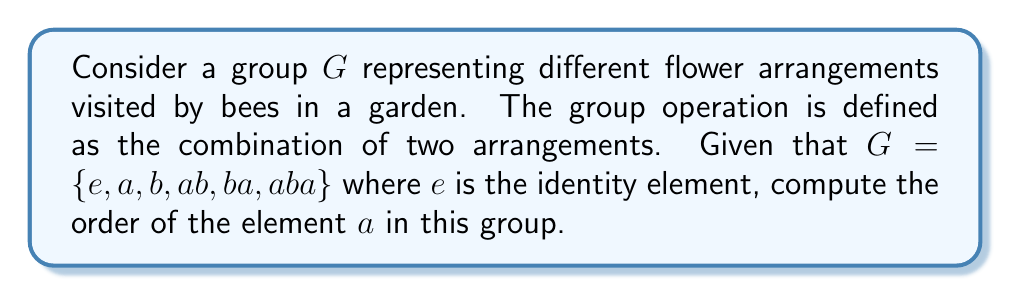What is the answer to this math problem? To find the order of element $a$ in group $G$, we need to determine the smallest positive integer $n$ such that $a^n = e$, where $e$ is the identity element.

Let's compute the powers of $a$:

1) $a^1 = a$
2) $a^2 = aa = b$ (given in the group elements)
3) $a^3 = a(a^2) = ab$
4) $a^4 = a(a^3) = a(ab) = aba$
5) $a^5 = a(a^4) = a(aba) = ba$
6) $a^6 = a(a^5) = a(ba) = e$

We see that $a^6 = e$, and this is the smallest positive integer for which this equality holds.

Note: This group represents the symmetries of a triangle, also known as the dihedral group $D_3$ or $S_3$.
Answer: The order of element $a$ in the given group $G$ is 6. 